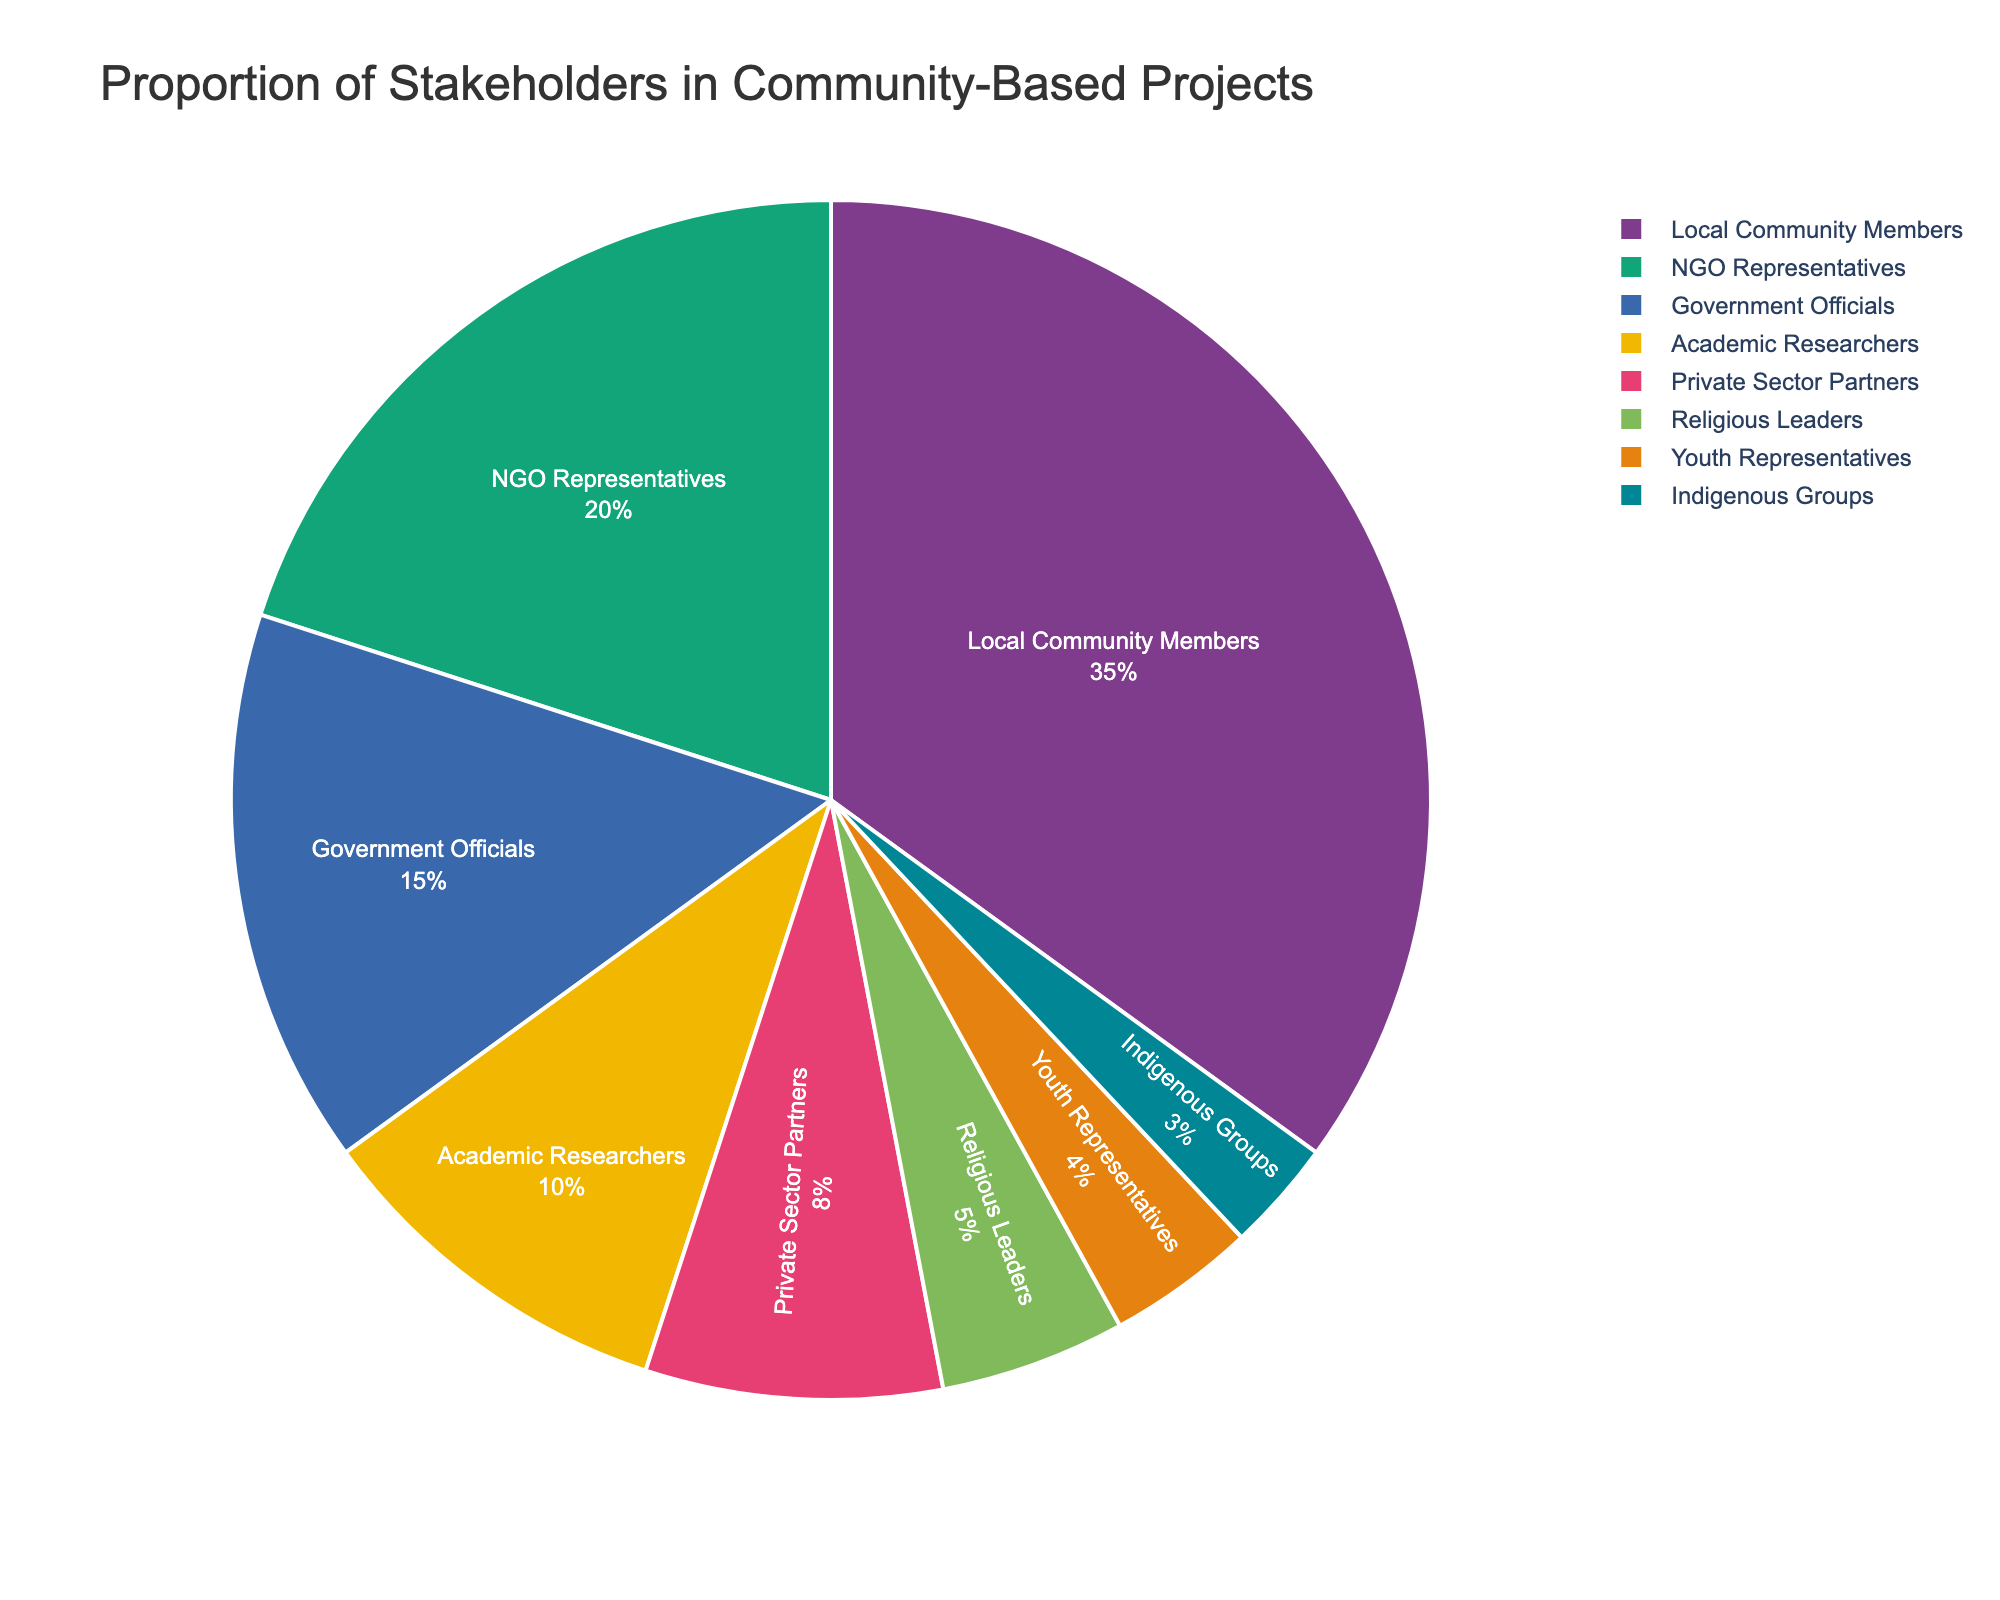What type of stakeholder has the highest proportion in community-based projects? Look at the pie chart and identify the slice with the largest size. The label for this slice will indicate the type of stakeholder.
Answer: Local Community Members What percentage of stakeholders are NGO Representatives? Locate the slice labeled "NGO Representatives" and read the percentage value associated with it in the pie chart.
Answer: 20% Which stakeholder group has a smaller proportion, Youth Representatives or Indigenous Groups? Compare the sizes of the slices labeled "Youth Representatives" and "Indigenous Groups". The slice with the smaller size represents the group with the smaller proportion.
Answer: Indigenous Groups What is the combined proportion of Government Officials and Academic Researchers? Find the percentages for Government Officials and Academic Researchers on the pie chart. Add these percentages together to get the combined proportion: 15% + 10% = 25%.
Answer: 25% Which stakeholders collectively make up more than 50% of the chart? Identify the stakeholders with the highest percentages. Add the values sequentially until you exceed 50%: Local Community Members (35%) + NGO Representatives (20%) = 55%.
Answer: Local Community Members and NGO Representatives Is the proportion of Private Sector Partners more or less than 10%? Find the slice for Private Sector Partners on the pie chart and check the percentage value listed.
Answer: Less than 10% By how much is the proportion of Local Community Members greater than that of Religious Leaders? Identify the percentages for Local Community Members and Religious Leaders. Subtract the percentage of Religious Leaders from that of Local Community Members: 35% - 5% = 30%.
Answer: 30% How many stakeholder types have a proportion under 10%? Identify all the slices with percentages under 10%: Academic Researchers (10%), Private Sector Partners (8%), Religious Leaders (5%), Youth Representatives (4%), Indigenous Groups (3%). Count these slices.
Answer: 5 What is the ratio of NGO Representatives to Private Sector Partners? Identify the percentages of NGO Representatives and Private Sector Partners. Divide the larger percentage by the smaller percentage to determine the ratio: 20% / 8% = 2.5.
Answer: 2.5 Which stakeholder group has the least representation in community-based projects? Find the smallest slice on the pie chart and read the label associated with it.
Answer: Indigenous Groups 